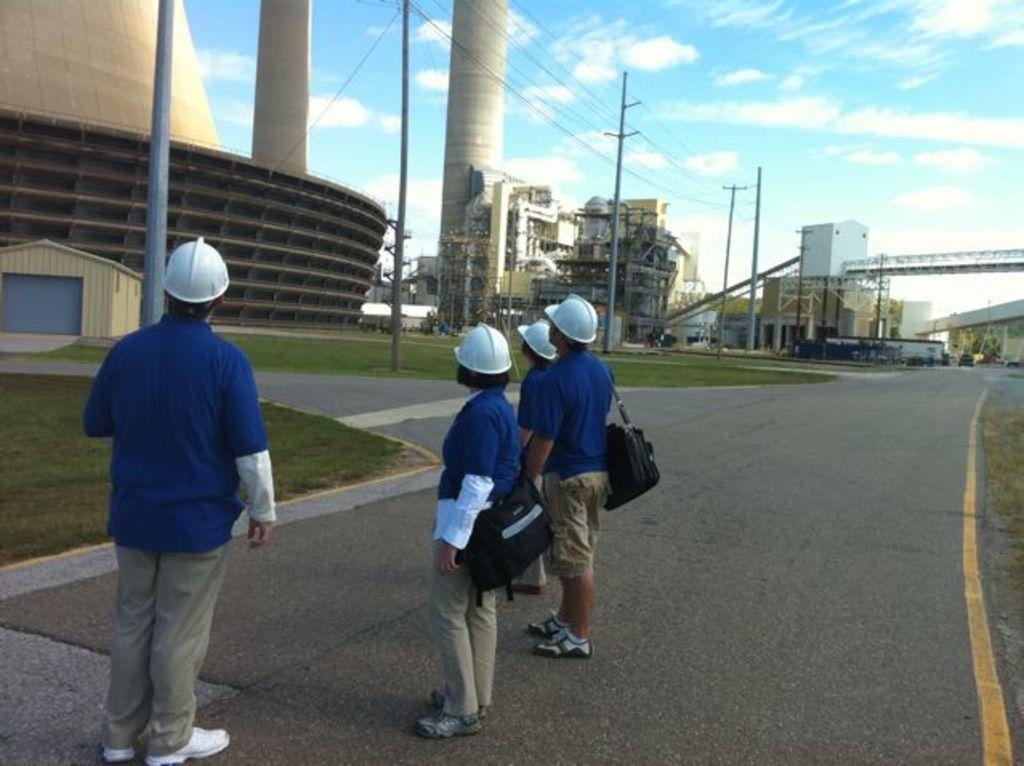Could you give a brief overview of what you see in this image? There are four persons on the road. This is grass. Here we can see poles, buildings, and vehicles. In the background there is sky with clouds. 